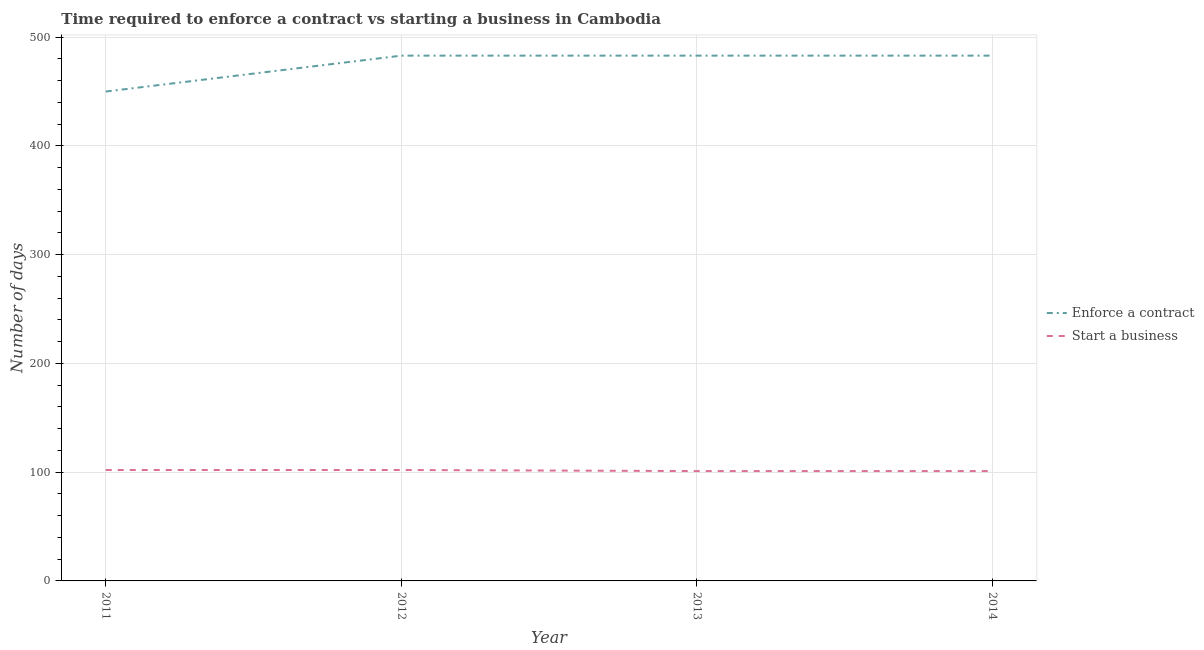How many different coloured lines are there?
Make the answer very short. 2. Is the number of lines equal to the number of legend labels?
Provide a short and direct response. Yes. What is the number of days to start a business in 2014?
Make the answer very short. 101. Across all years, what is the maximum number of days to start a business?
Your response must be concise. 102. Across all years, what is the minimum number of days to start a business?
Keep it short and to the point. 101. In which year was the number of days to start a business minimum?
Give a very brief answer. 2013. What is the total number of days to enforece a contract in the graph?
Your answer should be very brief. 1899. What is the difference between the number of days to start a business in 2011 and the number of days to enforece a contract in 2012?
Offer a terse response. -381. What is the average number of days to enforece a contract per year?
Your answer should be very brief. 474.75. In the year 2014, what is the difference between the number of days to start a business and number of days to enforece a contract?
Offer a very short reply. -382. What is the ratio of the number of days to enforece a contract in 2011 to that in 2013?
Keep it short and to the point. 0.93. What is the difference between the highest and the second highest number of days to start a business?
Your answer should be very brief. 0. What is the difference between the highest and the lowest number of days to start a business?
Make the answer very short. 1. In how many years, is the number of days to start a business greater than the average number of days to start a business taken over all years?
Provide a succinct answer. 2. Does the number of days to enforece a contract monotonically increase over the years?
Your answer should be very brief. No. Is the number of days to enforece a contract strictly greater than the number of days to start a business over the years?
Offer a terse response. Yes. How many lines are there?
Provide a short and direct response. 2. How many years are there in the graph?
Make the answer very short. 4. What is the difference between two consecutive major ticks on the Y-axis?
Offer a very short reply. 100. Are the values on the major ticks of Y-axis written in scientific E-notation?
Your answer should be very brief. No. Does the graph contain any zero values?
Ensure brevity in your answer.  No. How many legend labels are there?
Provide a succinct answer. 2. How are the legend labels stacked?
Your answer should be very brief. Vertical. What is the title of the graph?
Your response must be concise. Time required to enforce a contract vs starting a business in Cambodia. Does "Grants" appear as one of the legend labels in the graph?
Provide a succinct answer. No. What is the label or title of the X-axis?
Your answer should be compact. Year. What is the label or title of the Y-axis?
Your response must be concise. Number of days. What is the Number of days in Enforce a contract in 2011?
Provide a succinct answer. 450. What is the Number of days of Start a business in 2011?
Your answer should be very brief. 102. What is the Number of days in Enforce a contract in 2012?
Offer a terse response. 483. What is the Number of days of Start a business in 2012?
Offer a terse response. 102. What is the Number of days of Enforce a contract in 2013?
Keep it short and to the point. 483. What is the Number of days in Start a business in 2013?
Your answer should be very brief. 101. What is the Number of days of Enforce a contract in 2014?
Offer a terse response. 483. What is the Number of days of Start a business in 2014?
Provide a succinct answer. 101. Across all years, what is the maximum Number of days of Enforce a contract?
Offer a very short reply. 483. Across all years, what is the maximum Number of days in Start a business?
Your answer should be compact. 102. Across all years, what is the minimum Number of days of Enforce a contract?
Offer a terse response. 450. Across all years, what is the minimum Number of days of Start a business?
Offer a very short reply. 101. What is the total Number of days of Enforce a contract in the graph?
Your response must be concise. 1899. What is the total Number of days in Start a business in the graph?
Ensure brevity in your answer.  406. What is the difference between the Number of days of Enforce a contract in 2011 and that in 2012?
Offer a terse response. -33. What is the difference between the Number of days of Start a business in 2011 and that in 2012?
Give a very brief answer. 0. What is the difference between the Number of days of Enforce a contract in 2011 and that in 2013?
Offer a very short reply. -33. What is the difference between the Number of days of Enforce a contract in 2011 and that in 2014?
Keep it short and to the point. -33. What is the difference between the Number of days in Enforce a contract in 2012 and that in 2013?
Offer a terse response. 0. What is the difference between the Number of days of Enforce a contract in 2011 and the Number of days of Start a business in 2012?
Provide a short and direct response. 348. What is the difference between the Number of days in Enforce a contract in 2011 and the Number of days in Start a business in 2013?
Your answer should be compact. 349. What is the difference between the Number of days of Enforce a contract in 2011 and the Number of days of Start a business in 2014?
Your response must be concise. 349. What is the difference between the Number of days in Enforce a contract in 2012 and the Number of days in Start a business in 2013?
Make the answer very short. 382. What is the difference between the Number of days in Enforce a contract in 2012 and the Number of days in Start a business in 2014?
Offer a terse response. 382. What is the difference between the Number of days of Enforce a contract in 2013 and the Number of days of Start a business in 2014?
Give a very brief answer. 382. What is the average Number of days in Enforce a contract per year?
Your answer should be very brief. 474.75. What is the average Number of days of Start a business per year?
Your answer should be very brief. 101.5. In the year 2011, what is the difference between the Number of days in Enforce a contract and Number of days in Start a business?
Your response must be concise. 348. In the year 2012, what is the difference between the Number of days of Enforce a contract and Number of days of Start a business?
Offer a very short reply. 381. In the year 2013, what is the difference between the Number of days in Enforce a contract and Number of days in Start a business?
Make the answer very short. 382. In the year 2014, what is the difference between the Number of days in Enforce a contract and Number of days in Start a business?
Offer a terse response. 382. What is the ratio of the Number of days of Enforce a contract in 2011 to that in 2012?
Keep it short and to the point. 0.93. What is the ratio of the Number of days of Enforce a contract in 2011 to that in 2013?
Give a very brief answer. 0.93. What is the ratio of the Number of days of Start a business in 2011 to that in 2013?
Your answer should be compact. 1.01. What is the ratio of the Number of days in Enforce a contract in 2011 to that in 2014?
Provide a short and direct response. 0.93. What is the ratio of the Number of days of Start a business in 2011 to that in 2014?
Offer a very short reply. 1.01. What is the ratio of the Number of days of Enforce a contract in 2012 to that in 2013?
Your answer should be compact. 1. What is the ratio of the Number of days in Start a business in 2012 to that in 2013?
Give a very brief answer. 1.01. What is the ratio of the Number of days in Enforce a contract in 2012 to that in 2014?
Keep it short and to the point. 1. What is the ratio of the Number of days in Start a business in 2012 to that in 2014?
Provide a short and direct response. 1.01. What is the ratio of the Number of days in Enforce a contract in 2013 to that in 2014?
Keep it short and to the point. 1. What is the difference between the highest and the lowest Number of days of Enforce a contract?
Give a very brief answer. 33. 